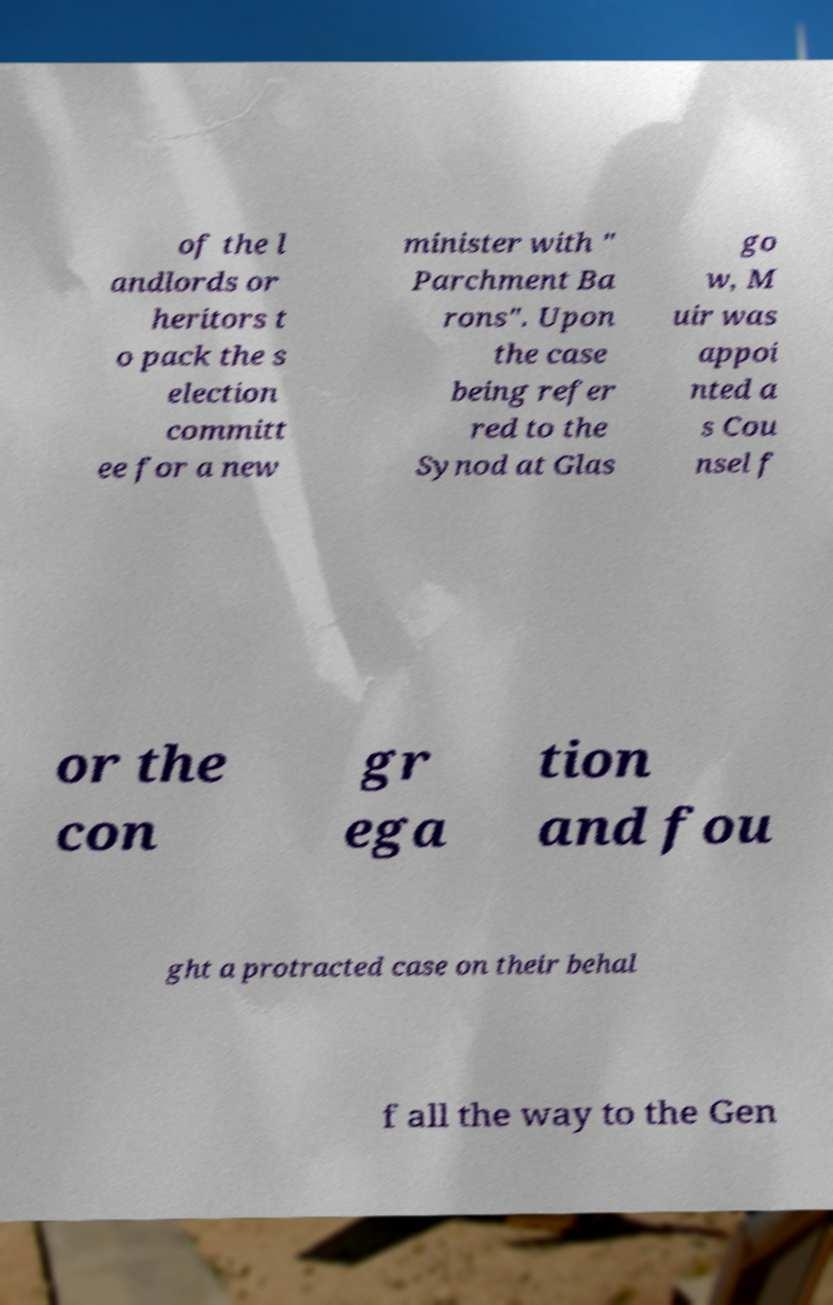Could you extract and type out the text from this image? of the l andlords or heritors t o pack the s election committ ee for a new minister with " Parchment Ba rons". Upon the case being refer red to the Synod at Glas go w, M uir was appoi nted a s Cou nsel f or the con gr ega tion and fou ght a protracted case on their behal f all the way to the Gen 